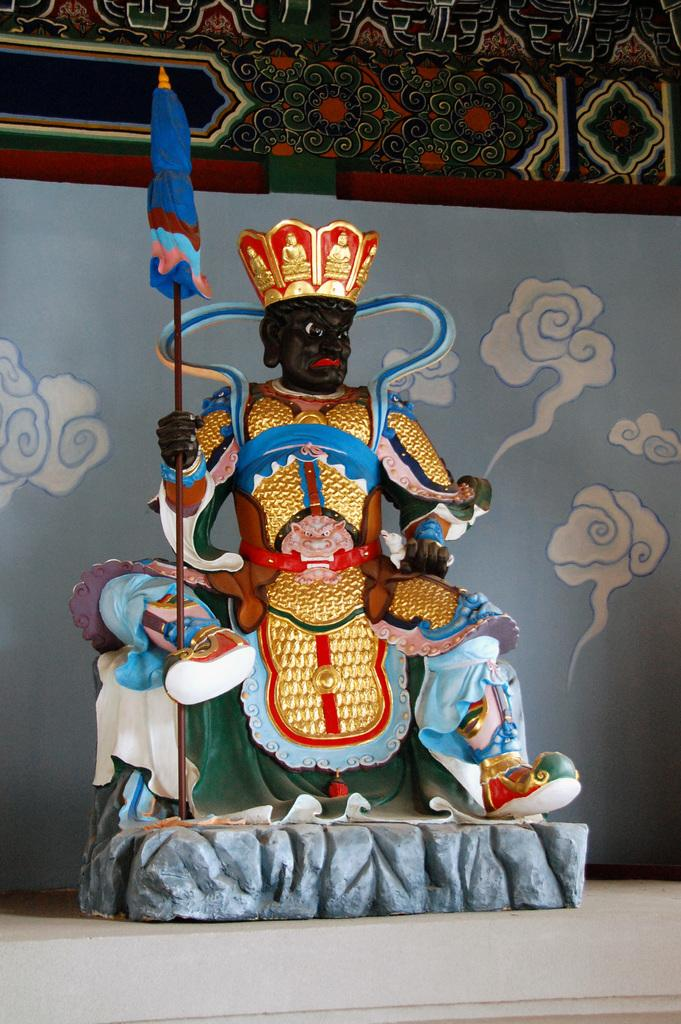What is the main subject in the middle of the image? There is a statue in the middle of the image. Where is the statue placed? The statue is placed over a location. What else can be seen in the image besides the statue? There is a curtain visible in the image. How many balls are being juggled by the statue in the image? There are no balls present in the image, and the statue is not depicted as juggling anything. 